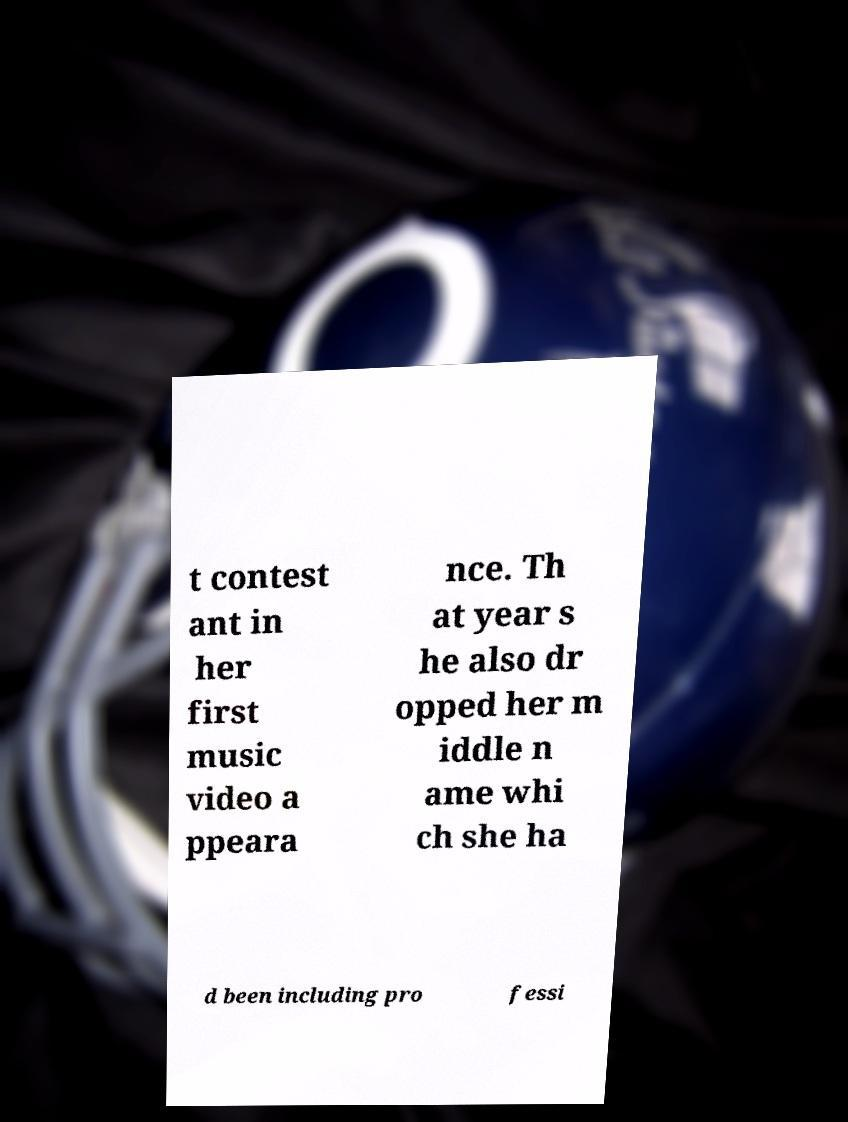I need the written content from this picture converted into text. Can you do that? t contest ant in her first music video a ppeara nce. Th at year s he also dr opped her m iddle n ame whi ch she ha d been including pro fessi 